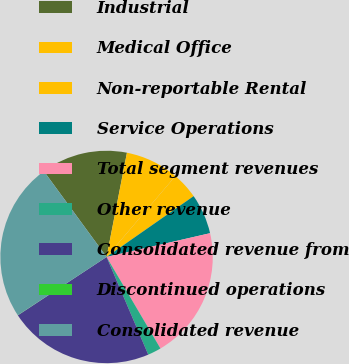<chart> <loc_0><loc_0><loc_500><loc_500><pie_chart><fcel>Industrial<fcel>Medical Office<fcel>Non-reportable Rental<fcel>Service Operations<fcel>Total segment revenues<fcel>Other revenue<fcel>Consolidated revenue from<fcel>Discontinued operations<fcel>Consolidated revenue<nl><fcel>13.12%<fcel>8.14%<fcel>4.08%<fcel>6.11%<fcel>20.12%<fcel>2.05%<fcel>22.15%<fcel>0.02%<fcel>24.19%<nl></chart> 